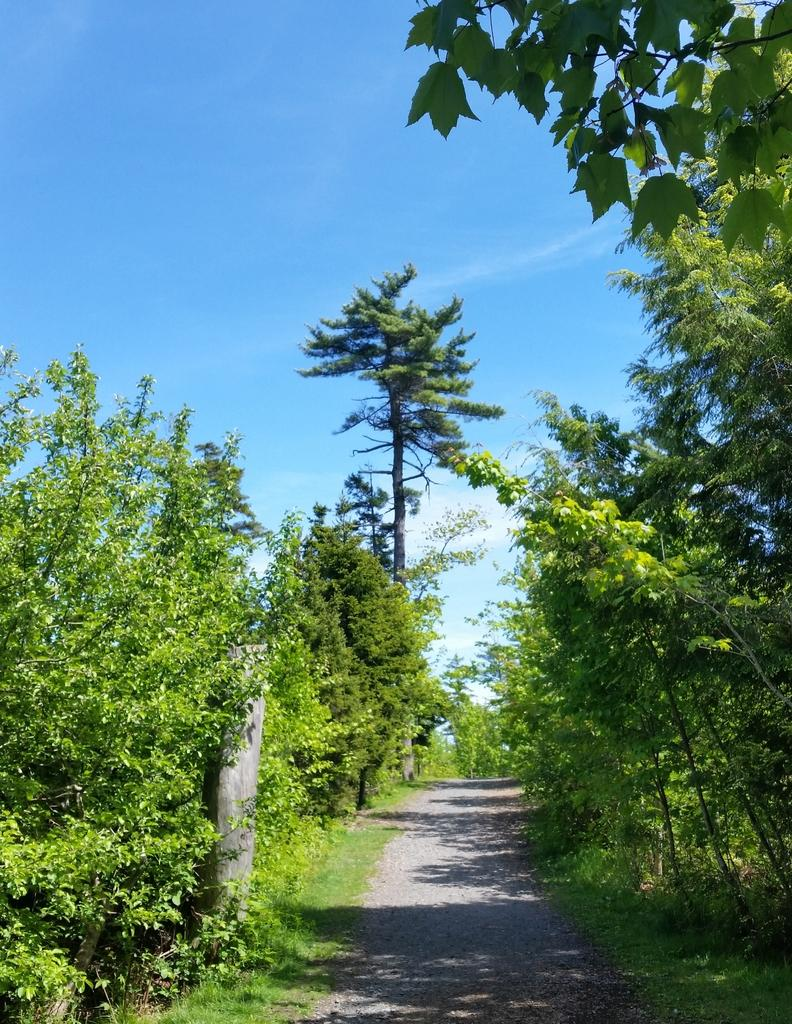What is the main feature in the middle of the image? There is a path in the middle of the image. What can be seen on both sides of the path? There are trees on both sides of the path. What is visible above the path and trees? The sky is visible in the image. Can you describe the sky in the image? There are patches of clouds in the sky. How does the fire affect the balance of the trees in the image? There is no fire present in the image, so it cannot affect the balance of the trees. 